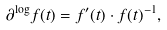Convert formula to latex. <formula><loc_0><loc_0><loc_500><loc_500>\partial ^ { \log } f ( t ) = f ^ { \prime } ( t ) \cdot f ( t ) ^ { - 1 } ,</formula> 